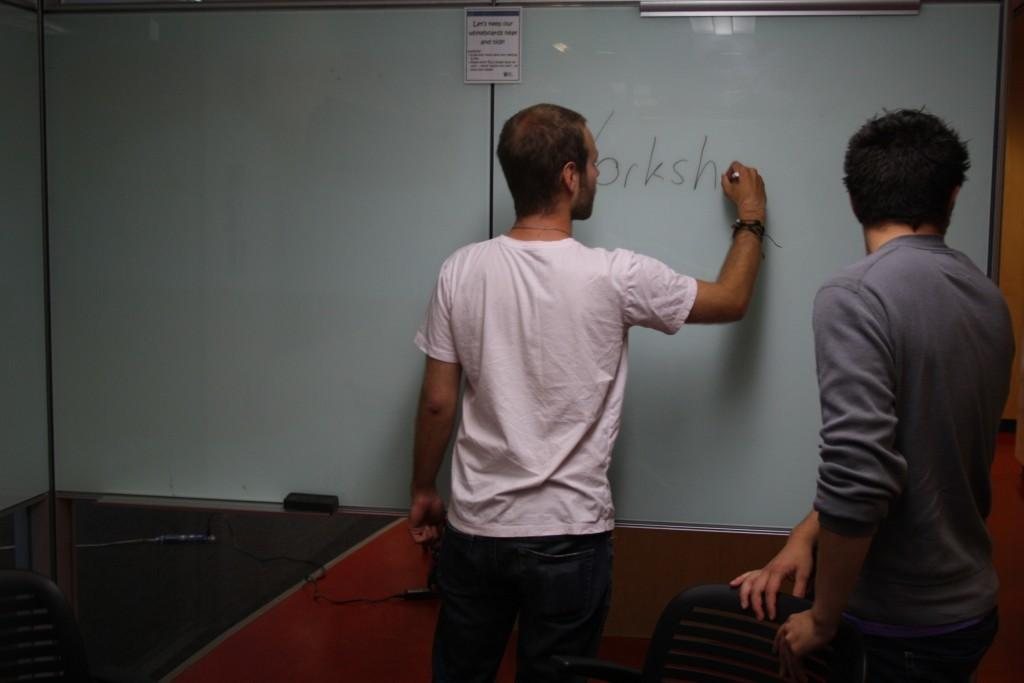<image>
Offer a succinct explanation of the picture presented. A man in a white shirt is standing in front of a white dry erase board, writing a word on it that ends in h. 